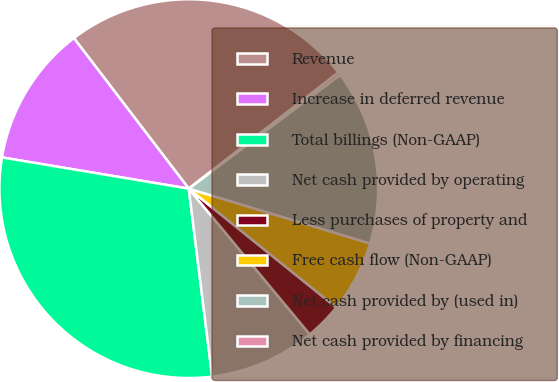Convert chart to OTSL. <chart><loc_0><loc_0><loc_500><loc_500><pie_chart><fcel>Revenue<fcel>Increase in deferred revenue<fcel>Total billings (Non-GAAP)<fcel>Net cash provided by operating<fcel>Less purchases of property and<fcel>Free cash flow (Non-GAAP)<fcel>Net cash provided by (used in)<fcel>Net cash provided by financing<nl><fcel>24.87%<fcel>11.99%<fcel>29.61%<fcel>9.06%<fcel>3.18%<fcel>6.12%<fcel>14.93%<fcel>0.25%<nl></chart> 